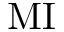<formula> <loc_0><loc_0><loc_500><loc_500>M I</formula> 